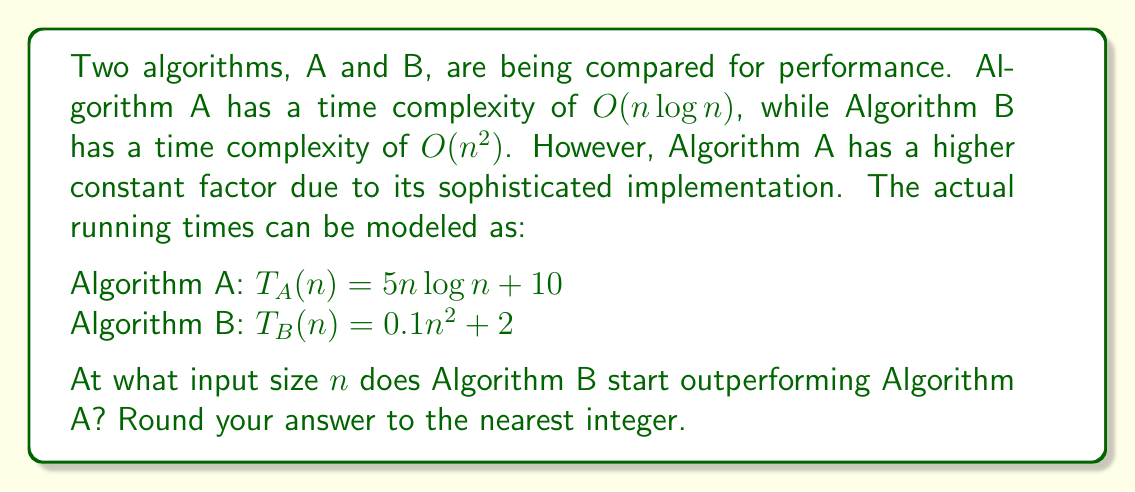What is the answer to this math problem? To find the point where Algorithm B starts outperforming Algorithm A, we need to find the value of $n$ where their running times are equal:

1) Set up the equation:
   $T_A(n) = T_B(n)$
   $5n \log n + 10 = 0.1n^2 + 2$

2) Rearrange the equation:
   $5n \log n - 0.1n^2 = -8$

3) This equation can't be solved algebraically, so we need to use numerical methods. Let's define a function:
   $f(n) = 5n \log n - 0.1n^2 + 8$

4) We're looking for the root of this function. We can use Newton's method or a binary search to find it.

5) Using a computational tool or calculator with root-finding capabilities, we find that the solution is approximately 21.9535.

6) Rounding to the nearest integer, we get 22.

7) To verify:
   At n = 22:
   $T_A(22) \approx 5 * 22 * \log 22 + 10 \approx 161.65$
   $T_B(22) \approx 0.1 * 22^2 + 2 \approx 50.4$

   At n = 23:
   $T_A(23) \approx 5 * 23 * \log 23 + 10 \approx 170.84$
   $T_B(23) \approx 0.1 * 23^2 + 2 \approx 54.9$

   We can see that Algorithm B starts outperforming Algorithm A after n = 22.
Answer: 22 